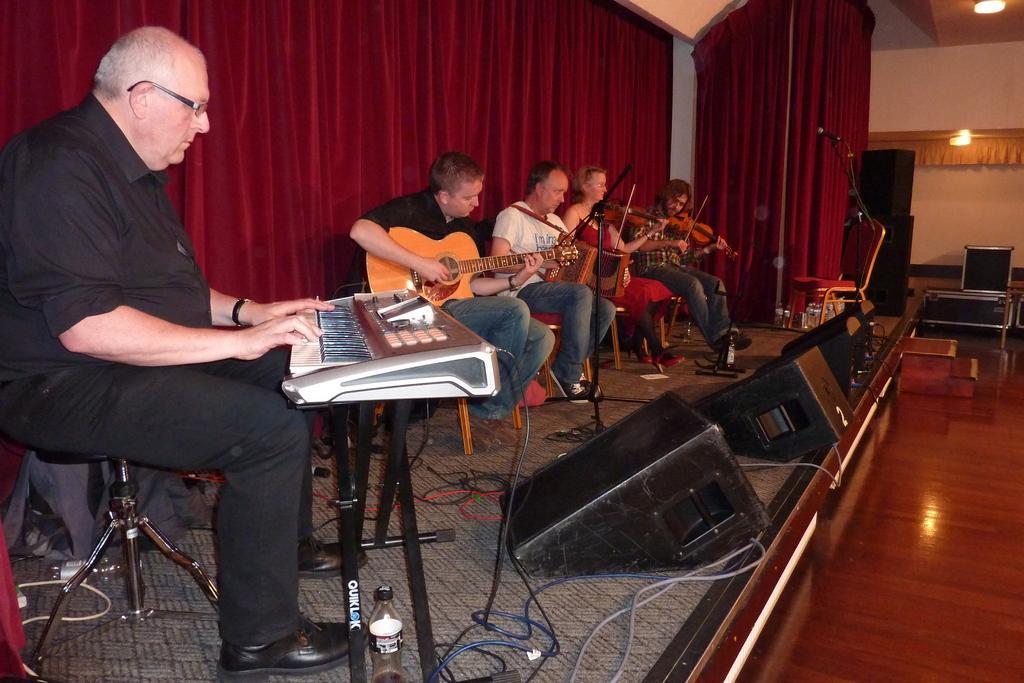Please provide a concise description of this image. In this image I see 5 persons sitting and all of them are with the musical instruments. In the background I see the curtain, wall and the lights. 